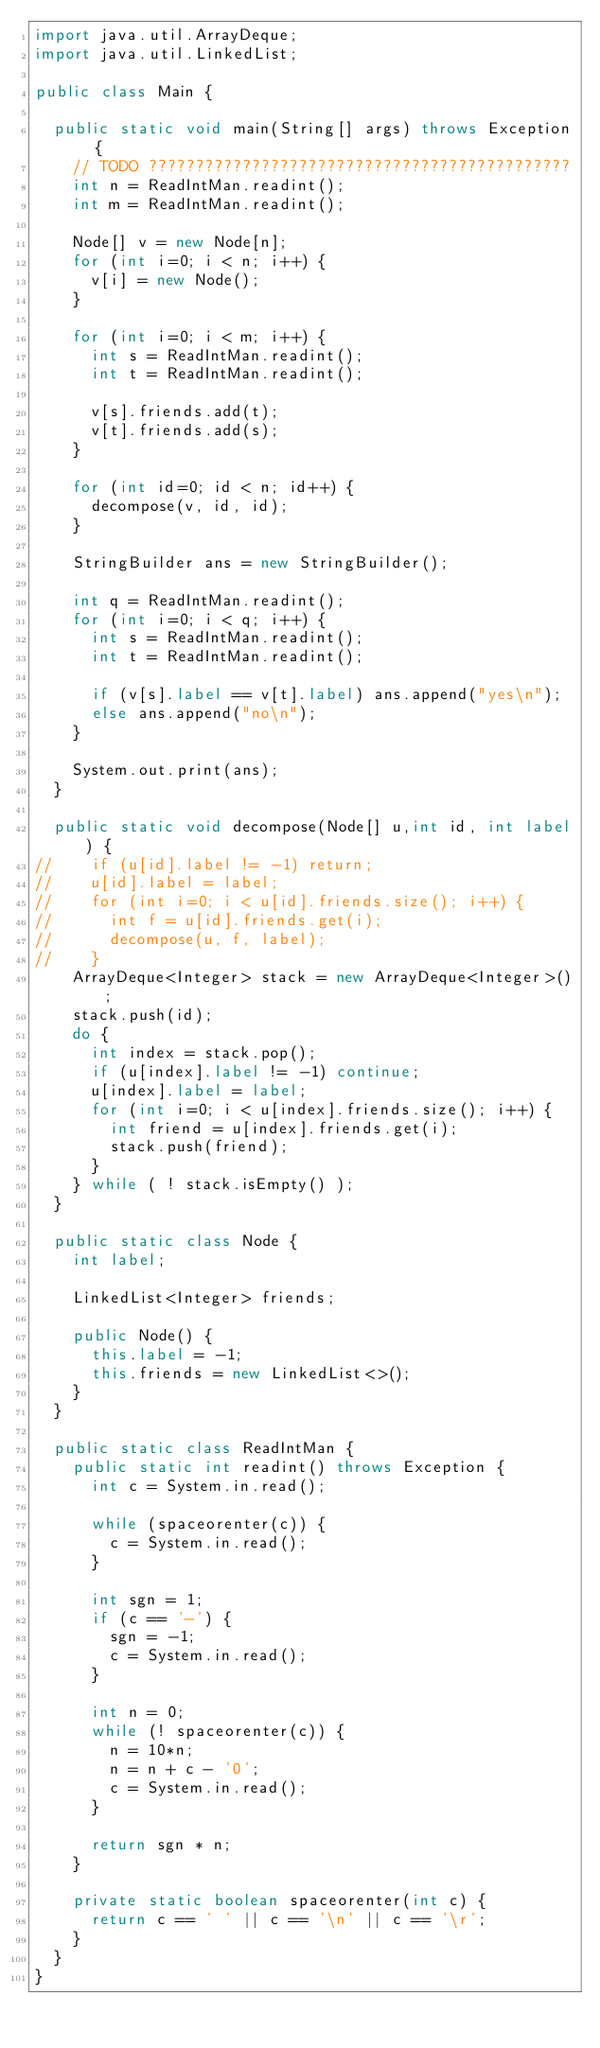<code> <loc_0><loc_0><loc_500><loc_500><_Java_>import java.util.ArrayDeque;
import java.util.LinkedList;

public class Main {

	public static void main(String[] args) throws Exception {
		// TODO ?????????????????????????????????????????????
		int n = ReadIntMan.readint();
		int m = ReadIntMan.readint();

		Node[] v = new Node[n];
		for (int i=0; i < n; i++) {
			v[i] = new Node();
		}

		for (int i=0; i < m; i++) {
			int s = ReadIntMan.readint();
			int t = ReadIntMan.readint();

			v[s].friends.add(t);
			v[t].friends.add(s);
		}

		for (int id=0; id < n; id++) {
			decompose(v, id, id);
		}

		StringBuilder ans = new StringBuilder();

		int q = ReadIntMan.readint();
		for (int i=0; i < q; i++) {
			int s = ReadIntMan.readint();
			int t = ReadIntMan.readint();

			if (v[s].label == v[t].label) ans.append("yes\n");
			else ans.append("no\n");
		}

		System.out.print(ans);
	}

	public static void decompose(Node[] u,int id, int label) {
//		if (u[id].label != -1) return;
//		u[id].label = label;
//		for (int i=0; i < u[id].friends.size(); i++) {
//			int f = u[id].friends.get(i);
//			decompose(u, f, label);
//		}
		ArrayDeque<Integer> stack = new ArrayDeque<Integer>();
		stack.push(id);
		do {
			int index = stack.pop();
			if (u[index].label != -1) continue;
			u[index].label = label;
			for (int i=0; i < u[index].friends.size(); i++) {
				int friend = u[index].friends.get(i);
				stack.push(friend);
			}
		} while ( ! stack.isEmpty() );
	}

	public static class Node {
		int label;

		LinkedList<Integer> friends;

		public Node() {
			this.label = -1;
			this.friends = new LinkedList<>();
		}
	}

	public static class ReadIntMan {
		public static int readint() throws Exception {
			int c = System.in.read();

			while (spaceorenter(c)) {
				c = System.in.read();
			}

			int sgn = 1;
			if (c == '-') {
				sgn = -1;
				c = System.in.read();
			}

			int n = 0;
			while (! spaceorenter(c)) {
				n = 10*n;
				n = n + c - '0';
				c = System.in.read();
			}

			return sgn * n;
		}

		private static boolean spaceorenter(int c) {
			return c == ' ' || c == '\n' || c == '\r';
		}
	}
}</code> 